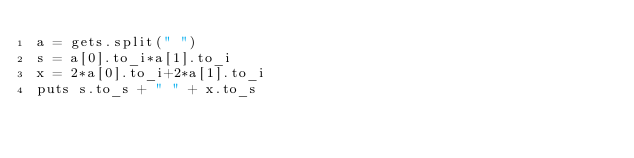<code> <loc_0><loc_0><loc_500><loc_500><_Ruby_>a = gets.split(" ")
s = a[0].to_i*a[1].to_i
x = 2*a[0].to_i+2*a[1].to_i
puts s.to_s + " " + x.to_s</code> 